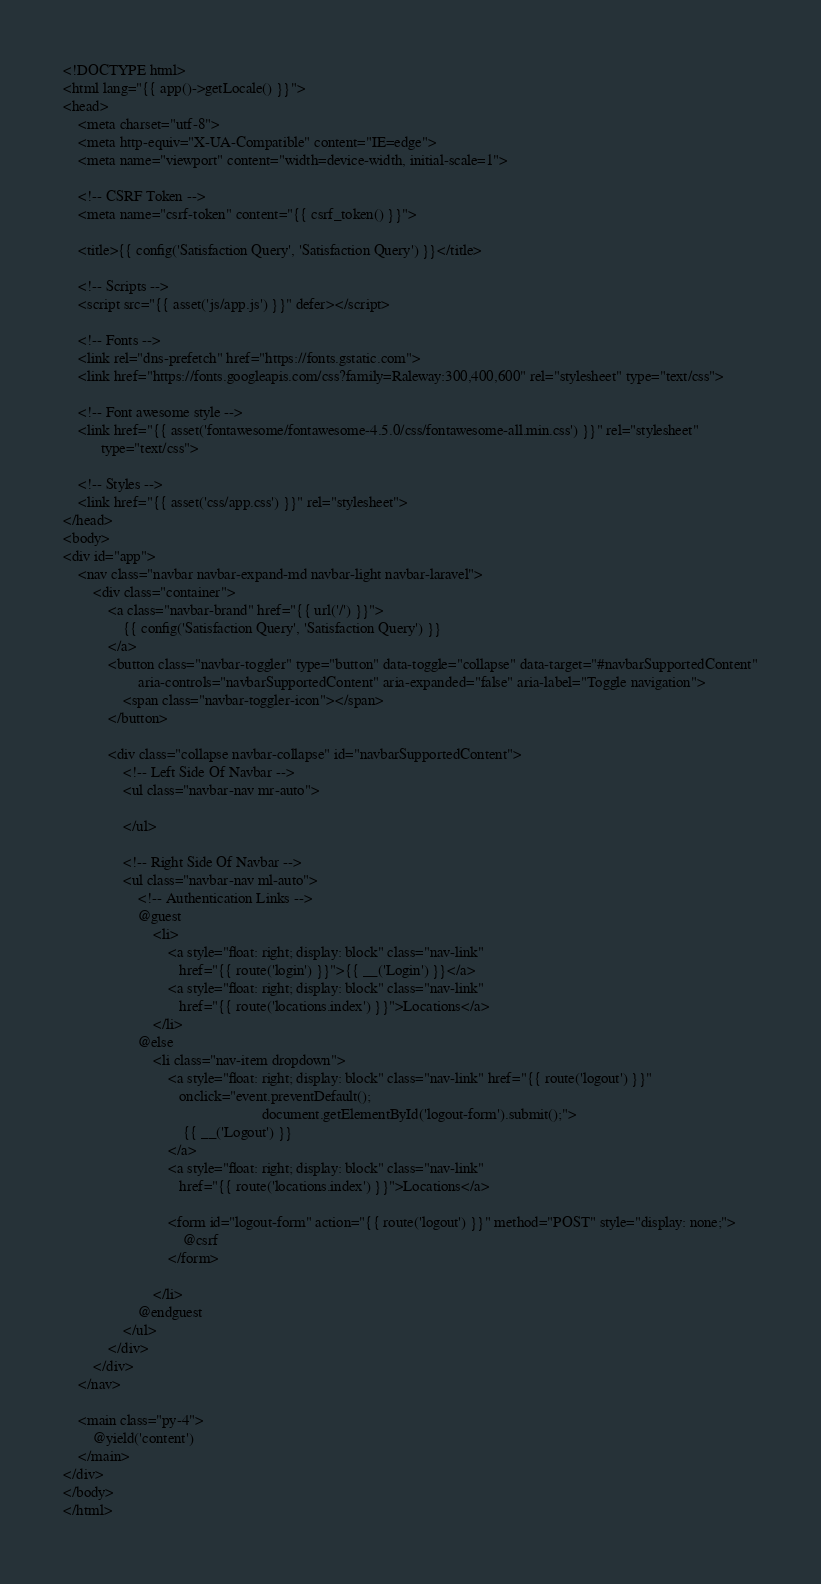Convert code to text. <code><loc_0><loc_0><loc_500><loc_500><_PHP_><!DOCTYPE html>
<html lang="{{ app()->getLocale() }}">
<head>
    <meta charset="utf-8">
    <meta http-equiv="X-UA-Compatible" content="IE=edge">
    <meta name="viewport" content="width=device-width, initial-scale=1">

    <!-- CSRF Token -->
    <meta name="csrf-token" content="{{ csrf_token() }}">

    <title>{{ config('Satisfaction Query', 'Satisfaction Query') }}</title>

    <!-- Scripts -->
    <script src="{{ asset('js/app.js') }}" defer></script>

    <!-- Fonts -->
    <link rel="dns-prefetch" href="https://fonts.gstatic.com">
    <link href="https://fonts.googleapis.com/css?family=Raleway:300,400,600" rel="stylesheet" type="text/css">

    <!-- Font awesome style -->
    <link href="{{ asset('fontawesome/fontawesome-4.5.0/css/fontawesome-all.min.css') }}" rel="stylesheet"
          type="text/css">

    <!-- Styles -->
    <link href="{{ asset('css/app.css') }}" rel="stylesheet">
</head>
<body>
<div id="app">
    <nav class="navbar navbar-expand-md navbar-light navbar-laravel">
        <div class="container">
            <a class="navbar-brand" href="{{ url('/') }}">
                {{ config('Satisfaction Query', 'Satisfaction Query') }}
            </a>
            <button class="navbar-toggler" type="button" data-toggle="collapse" data-target="#navbarSupportedContent"
                    aria-controls="navbarSupportedContent" aria-expanded="false" aria-label="Toggle navigation">
                <span class="navbar-toggler-icon"></span>
            </button>

            <div class="collapse navbar-collapse" id="navbarSupportedContent">
                <!-- Left Side Of Navbar -->
                <ul class="navbar-nav mr-auto">

                </ul>

                <!-- Right Side Of Navbar -->
                <ul class="navbar-nav ml-auto">
                    <!-- Authentication Links -->
                    @guest
                        <li>
                            <a style="float: right; display: block" class="nav-link"
                               href="{{ route('login') }}">{{ __('Login') }}</a>
                            <a style="float: right; display: block" class="nav-link"
                               href="{{ route('locations.index') }}">Locations</a>
                        </li>
                    @else
                        <li class="nav-item dropdown">
                            <a style="float: right; display: block" class="nav-link" href="{{ route('logout') }}"
                               onclick="event.preventDefault();
                                                     document.getElementById('logout-form').submit();">
                                {{ __('Logout') }}
                            </a>
                            <a style="float: right; display: block" class="nav-link"
                               href="{{ route('locations.index') }}">Locations</a>

                            <form id="logout-form" action="{{ route('logout') }}" method="POST" style="display: none;">
                                @csrf
                            </form>

                        </li>
                    @endguest
                </ul>
            </div>
        </div>
    </nav>

    <main class="py-4">
        @yield('content')
    </main>
</div>
</body>
</html>
</code> 